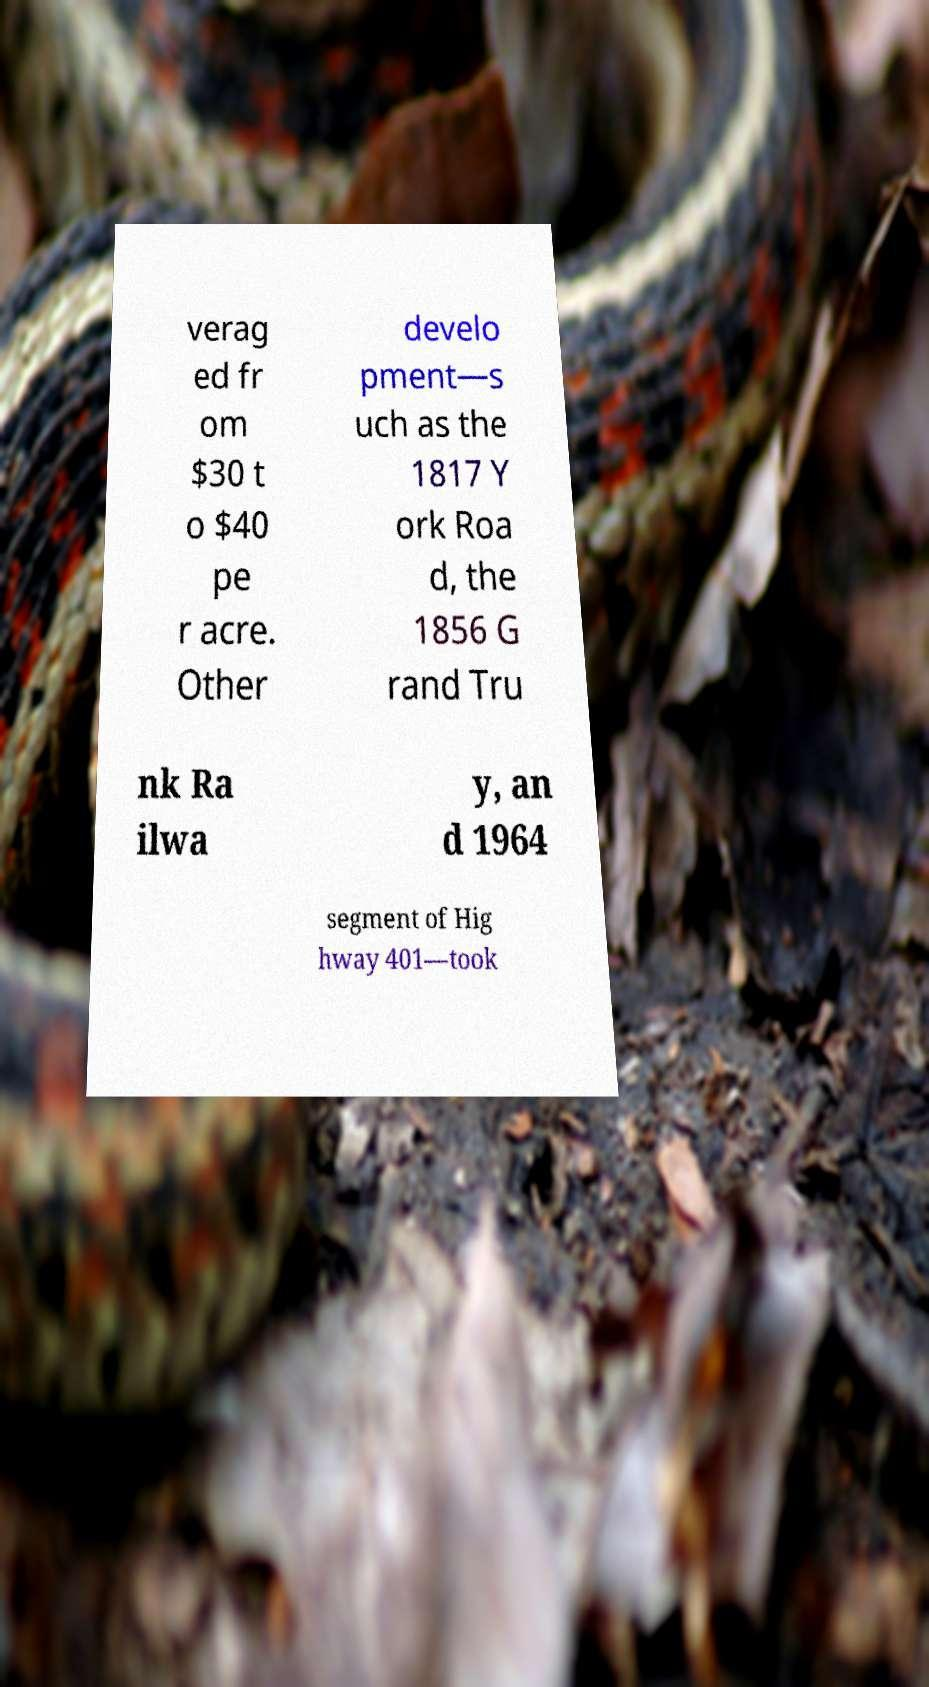I need the written content from this picture converted into text. Can you do that? verag ed fr om $30 t o $40 pe r acre. Other develo pment—s uch as the 1817 Y ork Roa d, the 1856 G rand Tru nk Ra ilwa y, an d 1964 segment of Hig hway 401—took 